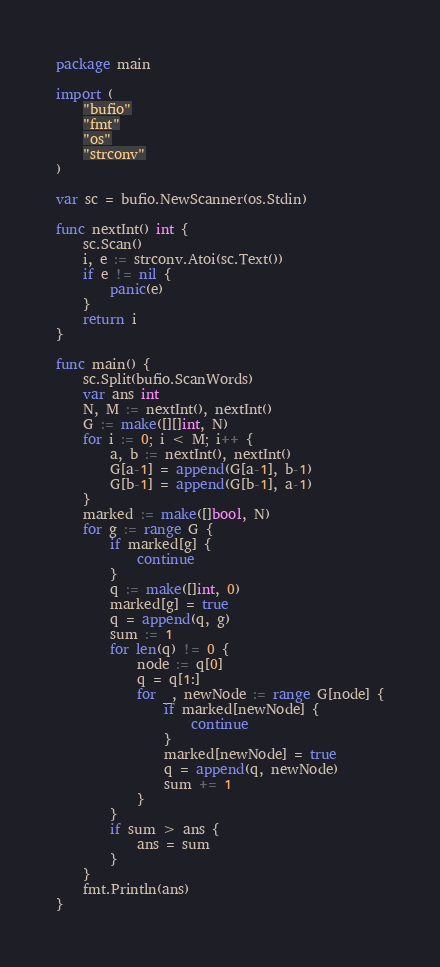<code> <loc_0><loc_0><loc_500><loc_500><_Go_>package main

import (
	"bufio"
	"fmt"
	"os"
	"strconv"
)

var sc = bufio.NewScanner(os.Stdin)

func nextInt() int {
	sc.Scan()
	i, e := strconv.Atoi(sc.Text())
	if e != nil {
		panic(e)
	}
	return i
}

func main() {
	sc.Split(bufio.ScanWords)
	var ans int
	N, M := nextInt(), nextInt()
	G := make([][]int, N)
	for i := 0; i < M; i++ {
		a, b := nextInt(), nextInt()
		G[a-1] = append(G[a-1], b-1)
		G[b-1] = append(G[b-1], a-1)
	}
	marked := make([]bool, N)
	for g := range G {
		if marked[g] {
			continue
		}
		q := make([]int, 0)
		marked[g] = true
		q = append(q, g)
		sum := 1
		for len(q) != 0 {
			node := q[0]
			q = q[1:]
			for _, newNode := range G[node] {
				if marked[newNode] {
					continue
				}
				marked[newNode] = true
				q = append(q, newNode)
				sum += 1
			}
		}
		if sum > ans {
			ans = sum
		}
	}
	fmt.Println(ans)
}
</code> 